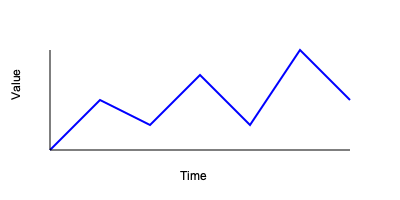Given the time series data visualization above, what type of pattern does this sequence most likely represent in the context of algorithm learning applications? To identify the pattern in this sequential data visualization, let's follow these steps:

1. Observe the overall trend: The line graph shows fluctuations with an overall upward trajectory from left to right.

2. Analyze the fluctuations: The data points alternate between higher and lower values, creating a series of peaks and troughs.

3. Consider the regularity: While not perfectly uniform, the oscillations appear to have a somewhat consistent frequency and amplitude.

4. Relate to algorithm learning: In the context of algorithm learning, this pattern resembles the learning curve of an iterative optimization algorithm, such as gradient descent or stochastic gradient descent.

5. Interpret the pattern:
   - The overall upward trend suggests improvement in the algorithm's performance over time.
   - The oscillations indicate that the algorithm's performance fluctuates between iterations.
   - The somewhat regular nature of the oscillations suggests a cyclical learning process.

6. Conclude: This pattern most closely resembles a "convergence with oscillations" behavior, which is common in iterative learning algorithms as they approach an optimal solution.

In algorithm learning applications, this pattern often indicates that the algorithm is making progress towards a solution but experiences some instability or overshooting in each iteration before eventually converging.
Answer: Convergence with oscillations 